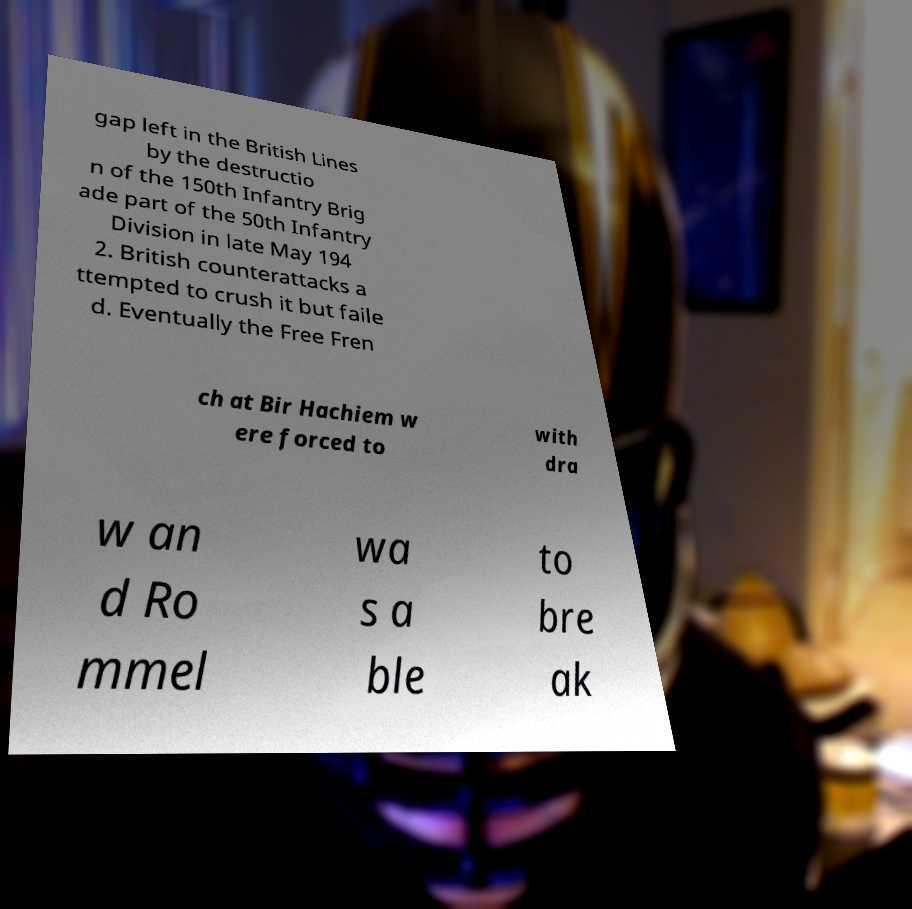What messages or text are displayed in this image? I need them in a readable, typed format. gap left in the British Lines by the destructio n of the 150th Infantry Brig ade part of the 50th Infantry Division in late May 194 2. British counterattacks a ttempted to crush it but faile d. Eventually the Free Fren ch at Bir Hachiem w ere forced to with dra w an d Ro mmel wa s a ble to bre ak 